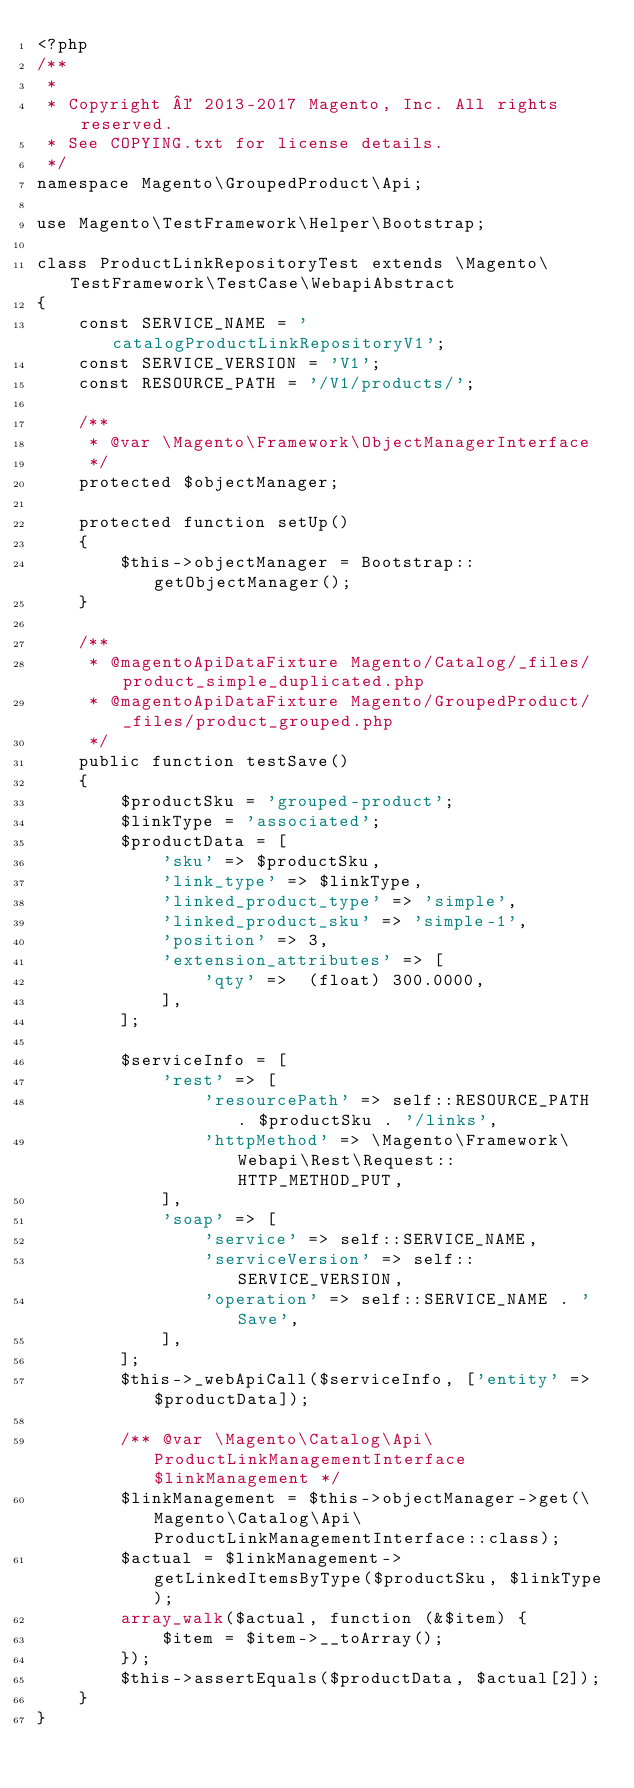Convert code to text. <code><loc_0><loc_0><loc_500><loc_500><_PHP_><?php
/**
 *
 * Copyright © 2013-2017 Magento, Inc. All rights reserved.
 * See COPYING.txt for license details.
 */
namespace Magento\GroupedProduct\Api;

use Magento\TestFramework\Helper\Bootstrap;

class ProductLinkRepositoryTest extends \Magento\TestFramework\TestCase\WebapiAbstract
{
    const SERVICE_NAME = 'catalogProductLinkRepositoryV1';
    const SERVICE_VERSION = 'V1';
    const RESOURCE_PATH = '/V1/products/';

    /**
     * @var \Magento\Framework\ObjectManagerInterface
     */
    protected $objectManager;

    protected function setUp()
    {
        $this->objectManager = Bootstrap::getObjectManager();
    }

    /**
     * @magentoApiDataFixture Magento/Catalog/_files/product_simple_duplicated.php
     * @magentoApiDataFixture Magento/GroupedProduct/_files/product_grouped.php
     */
    public function testSave()
    {
        $productSku = 'grouped-product';
        $linkType = 'associated';
        $productData = [
            'sku' => $productSku,
            'link_type' => $linkType,
            'linked_product_type' => 'simple',
            'linked_product_sku' => 'simple-1',
            'position' => 3,
            'extension_attributes' => [
                'qty' =>  (float) 300.0000,
            ],
        ];

        $serviceInfo = [
            'rest' => [
                'resourcePath' => self::RESOURCE_PATH . $productSku . '/links',
                'httpMethod' => \Magento\Framework\Webapi\Rest\Request::HTTP_METHOD_PUT,
            ],
            'soap' => [
                'service' => self::SERVICE_NAME,
                'serviceVersion' => self::SERVICE_VERSION,
                'operation' => self::SERVICE_NAME . 'Save',
            ],
        ];
        $this->_webApiCall($serviceInfo, ['entity' => $productData]);

        /** @var \Magento\Catalog\Api\ProductLinkManagementInterface $linkManagement */
        $linkManagement = $this->objectManager->get(\Magento\Catalog\Api\ProductLinkManagementInterface::class);
        $actual = $linkManagement->getLinkedItemsByType($productSku, $linkType);
        array_walk($actual, function (&$item) {
            $item = $item->__toArray();
        });
        $this->assertEquals($productData, $actual[2]);
    }
}
</code> 